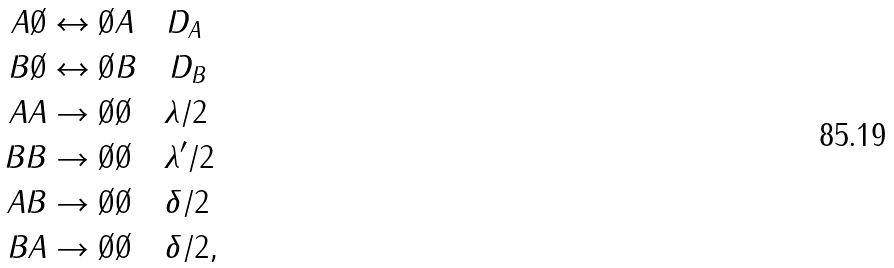<formula> <loc_0><loc_0><loc_500><loc_500>A \emptyset & \leftrightarrow \emptyset A \quad D _ { A } \\ B \emptyset & \leftrightarrow \emptyset B \quad D _ { B } \\ A A & \to \emptyset \emptyset \quad \lambda / 2 \\ B B & \to \emptyset \emptyset \quad \lambda ^ { \prime } / 2 \\ A B & \to \emptyset \emptyset \quad \delta / 2 \\ B A & \to \emptyset \emptyset \quad \delta / 2 ,</formula> 